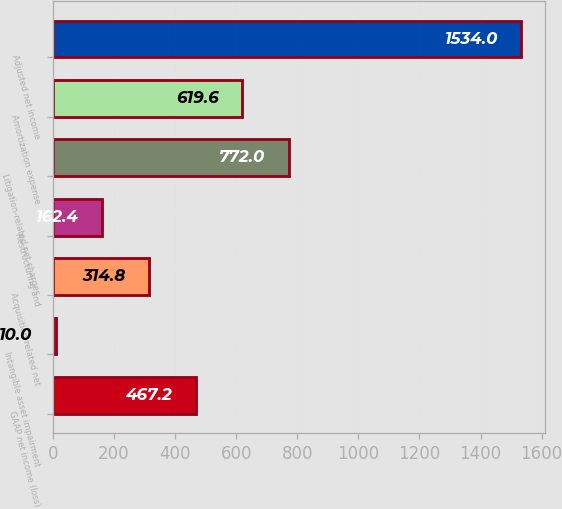Convert chart. <chart><loc_0><loc_0><loc_500><loc_500><bar_chart><fcel>GAAP net income (loss)<fcel>Intangible asset impairment<fcel>Acquisition-related net<fcel>Restructuring and<fcel>Litigation-related net charges<fcel>Amortization expense<fcel>Adjusted net income<nl><fcel>467.2<fcel>10<fcel>314.8<fcel>162.4<fcel>772<fcel>619.6<fcel>1534<nl></chart> 